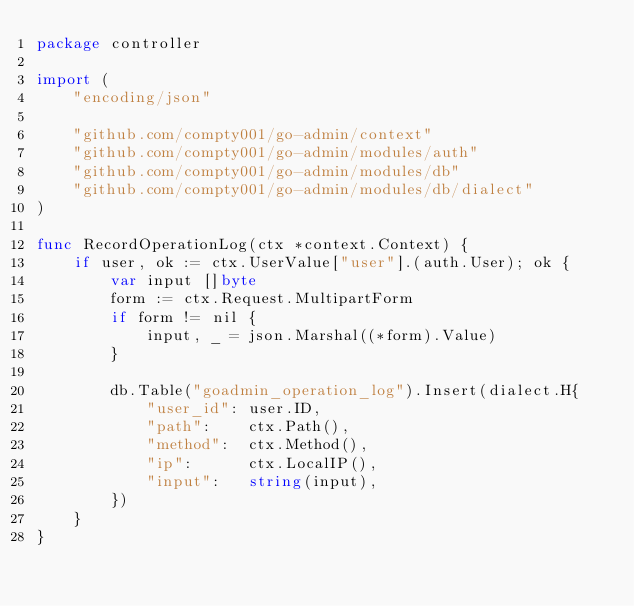<code> <loc_0><loc_0><loc_500><loc_500><_Go_>package controller

import (
	"encoding/json"

	"github.com/compty001/go-admin/context"
	"github.com/compty001/go-admin/modules/auth"
	"github.com/compty001/go-admin/modules/db"
	"github.com/compty001/go-admin/modules/db/dialect"
)

func RecordOperationLog(ctx *context.Context) {
	if user, ok := ctx.UserValue["user"].(auth.User); ok {
		var input []byte
		form := ctx.Request.MultipartForm
		if form != nil {
			input, _ = json.Marshal((*form).Value)
		}

		db.Table("goadmin_operation_log").Insert(dialect.H{
			"user_id": user.ID,
			"path":    ctx.Path(),
			"method":  ctx.Method(),
			"ip":      ctx.LocalIP(),
			"input":   string(input),
		})
	}
}
</code> 